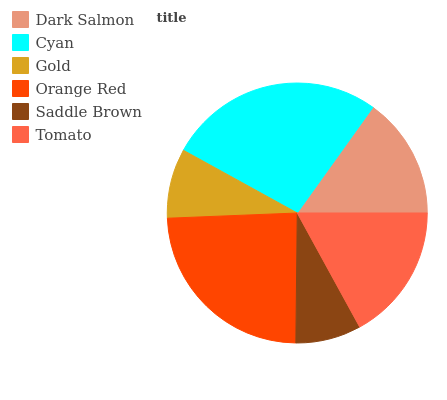Is Saddle Brown the minimum?
Answer yes or no. Yes. Is Cyan the maximum?
Answer yes or no. Yes. Is Gold the minimum?
Answer yes or no. No. Is Gold the maximum?
Answer yes or no. No. Is Cyan greater than Gold?
Answer yes or no. Yes. Is Gold less than Cyan?
Answer yes or no. Yes. Is Gold greater than Cyan?
Answer yes or no. No. Is Cyan less than Gold?
Answer yes or no. No. Is Tomato the high median?
Answer yes or no. Yes. Is Dark Salmon the low median?
Answer yes or no. Yes. Is Dark Salmon the high median?
Answer yes or no. No. Is Tomato the low median?
Answer yes or no. No. 